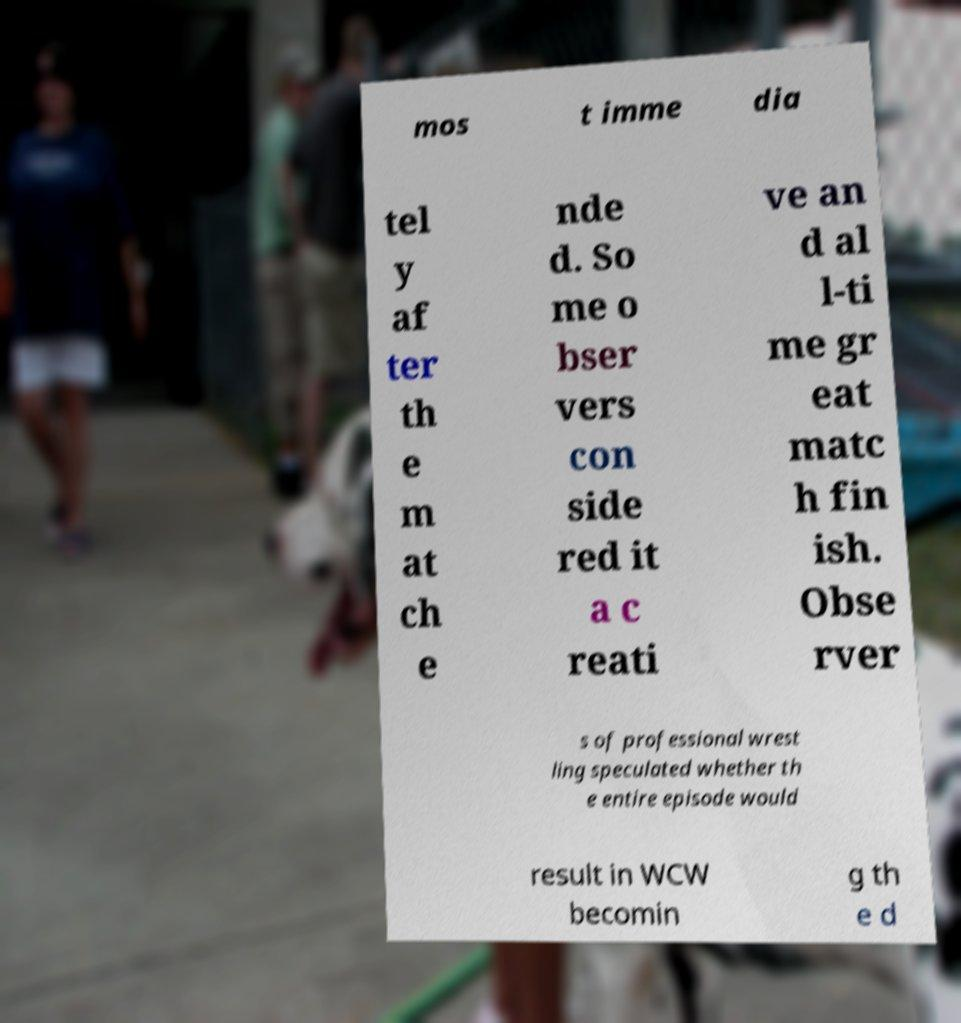I need the written content from this picture converted into text. Can you do that? mos t imme dia tel y af ter th e m at ch e nde d. So me o bser vers con side red it a c reati ve an d al l-ti me gr eat matc h fin ish. Obse rver s of professional wrest ling speculated whether th e entire episode would result in WCW becomin g th e d 